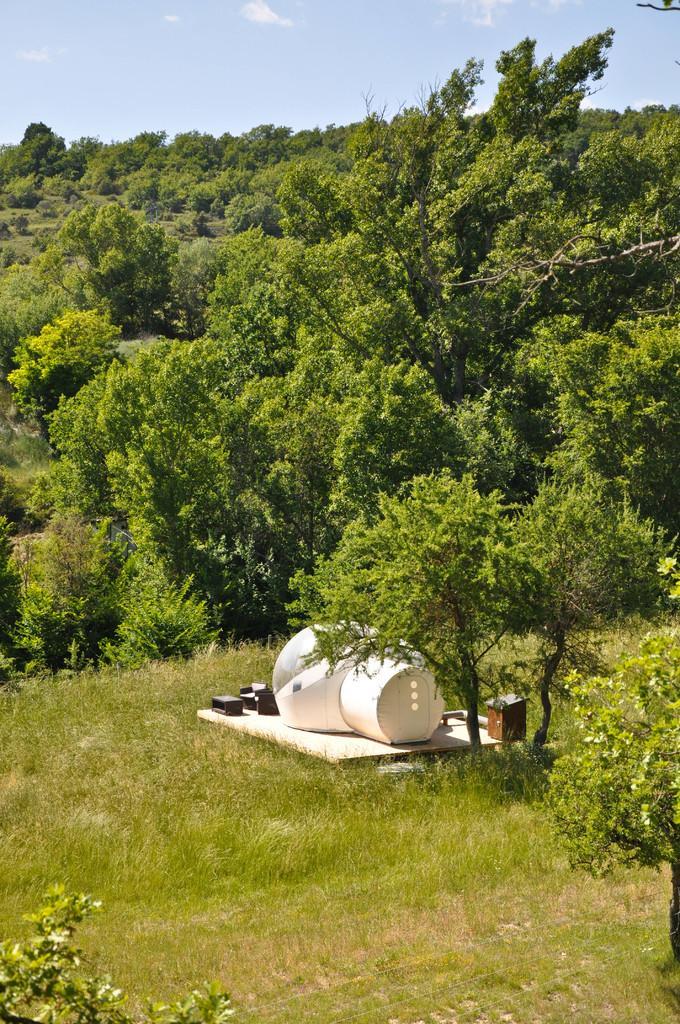How would you summarize this image in a sentence or two? In this image we can see there are trees, objects and grass. In the background we can see the sky. 